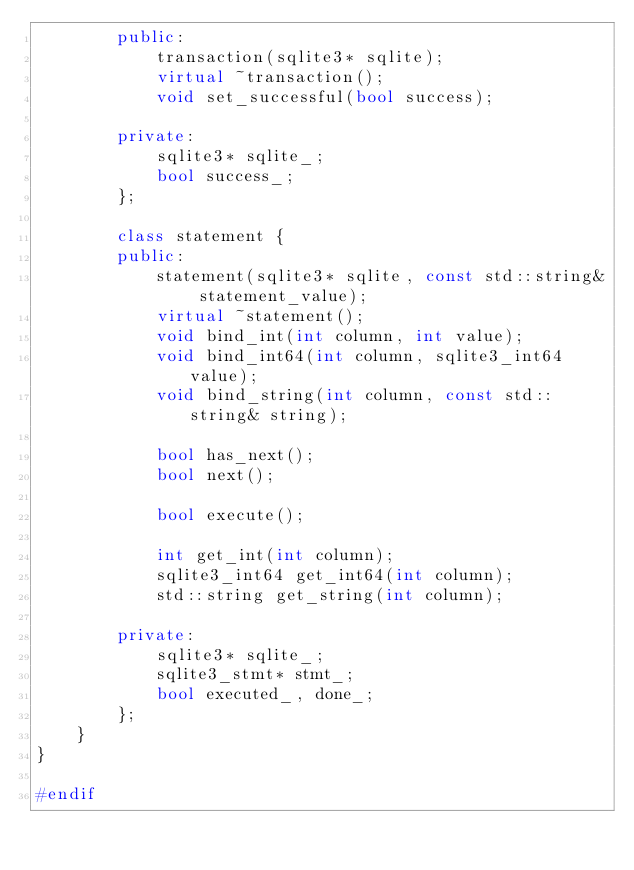<code> <loc_0><loc_0><loc_500><loc_500><_C++_>        public:
            transaction(sqlite3* sqlite);
            virtual ~transaction();
            void set_successful(bool success);

        private:
            sqlite3* sqlite_;
            bool success_;
        };

        class statement {
        public:
            statement(sqlite3* sqlite, const std::string& statement_value);
            virtual ~statement();
            void bind_int(int column, int value);
            void bind_int64(int column, sqlite3_int64 value);
            void bind_string(int column, const std::string& string);

            bool has_next();
            bool next();

            bool execute();

            int get_int(int column);
            sqlite3_int64 get_int64(int column);
            std::string get_string(int column);

        private:
            sqlite3* sqlite_;
            sqlite3_stmt* stmt_;
            bool executed_, done_;
        };
    }
}

#endif

</code> 